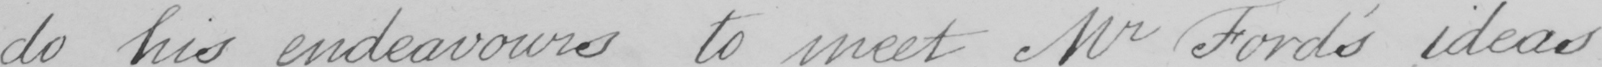Can you read and transcribe this handwriting? do his endeavours to meet Mr Ford ' s ideas 